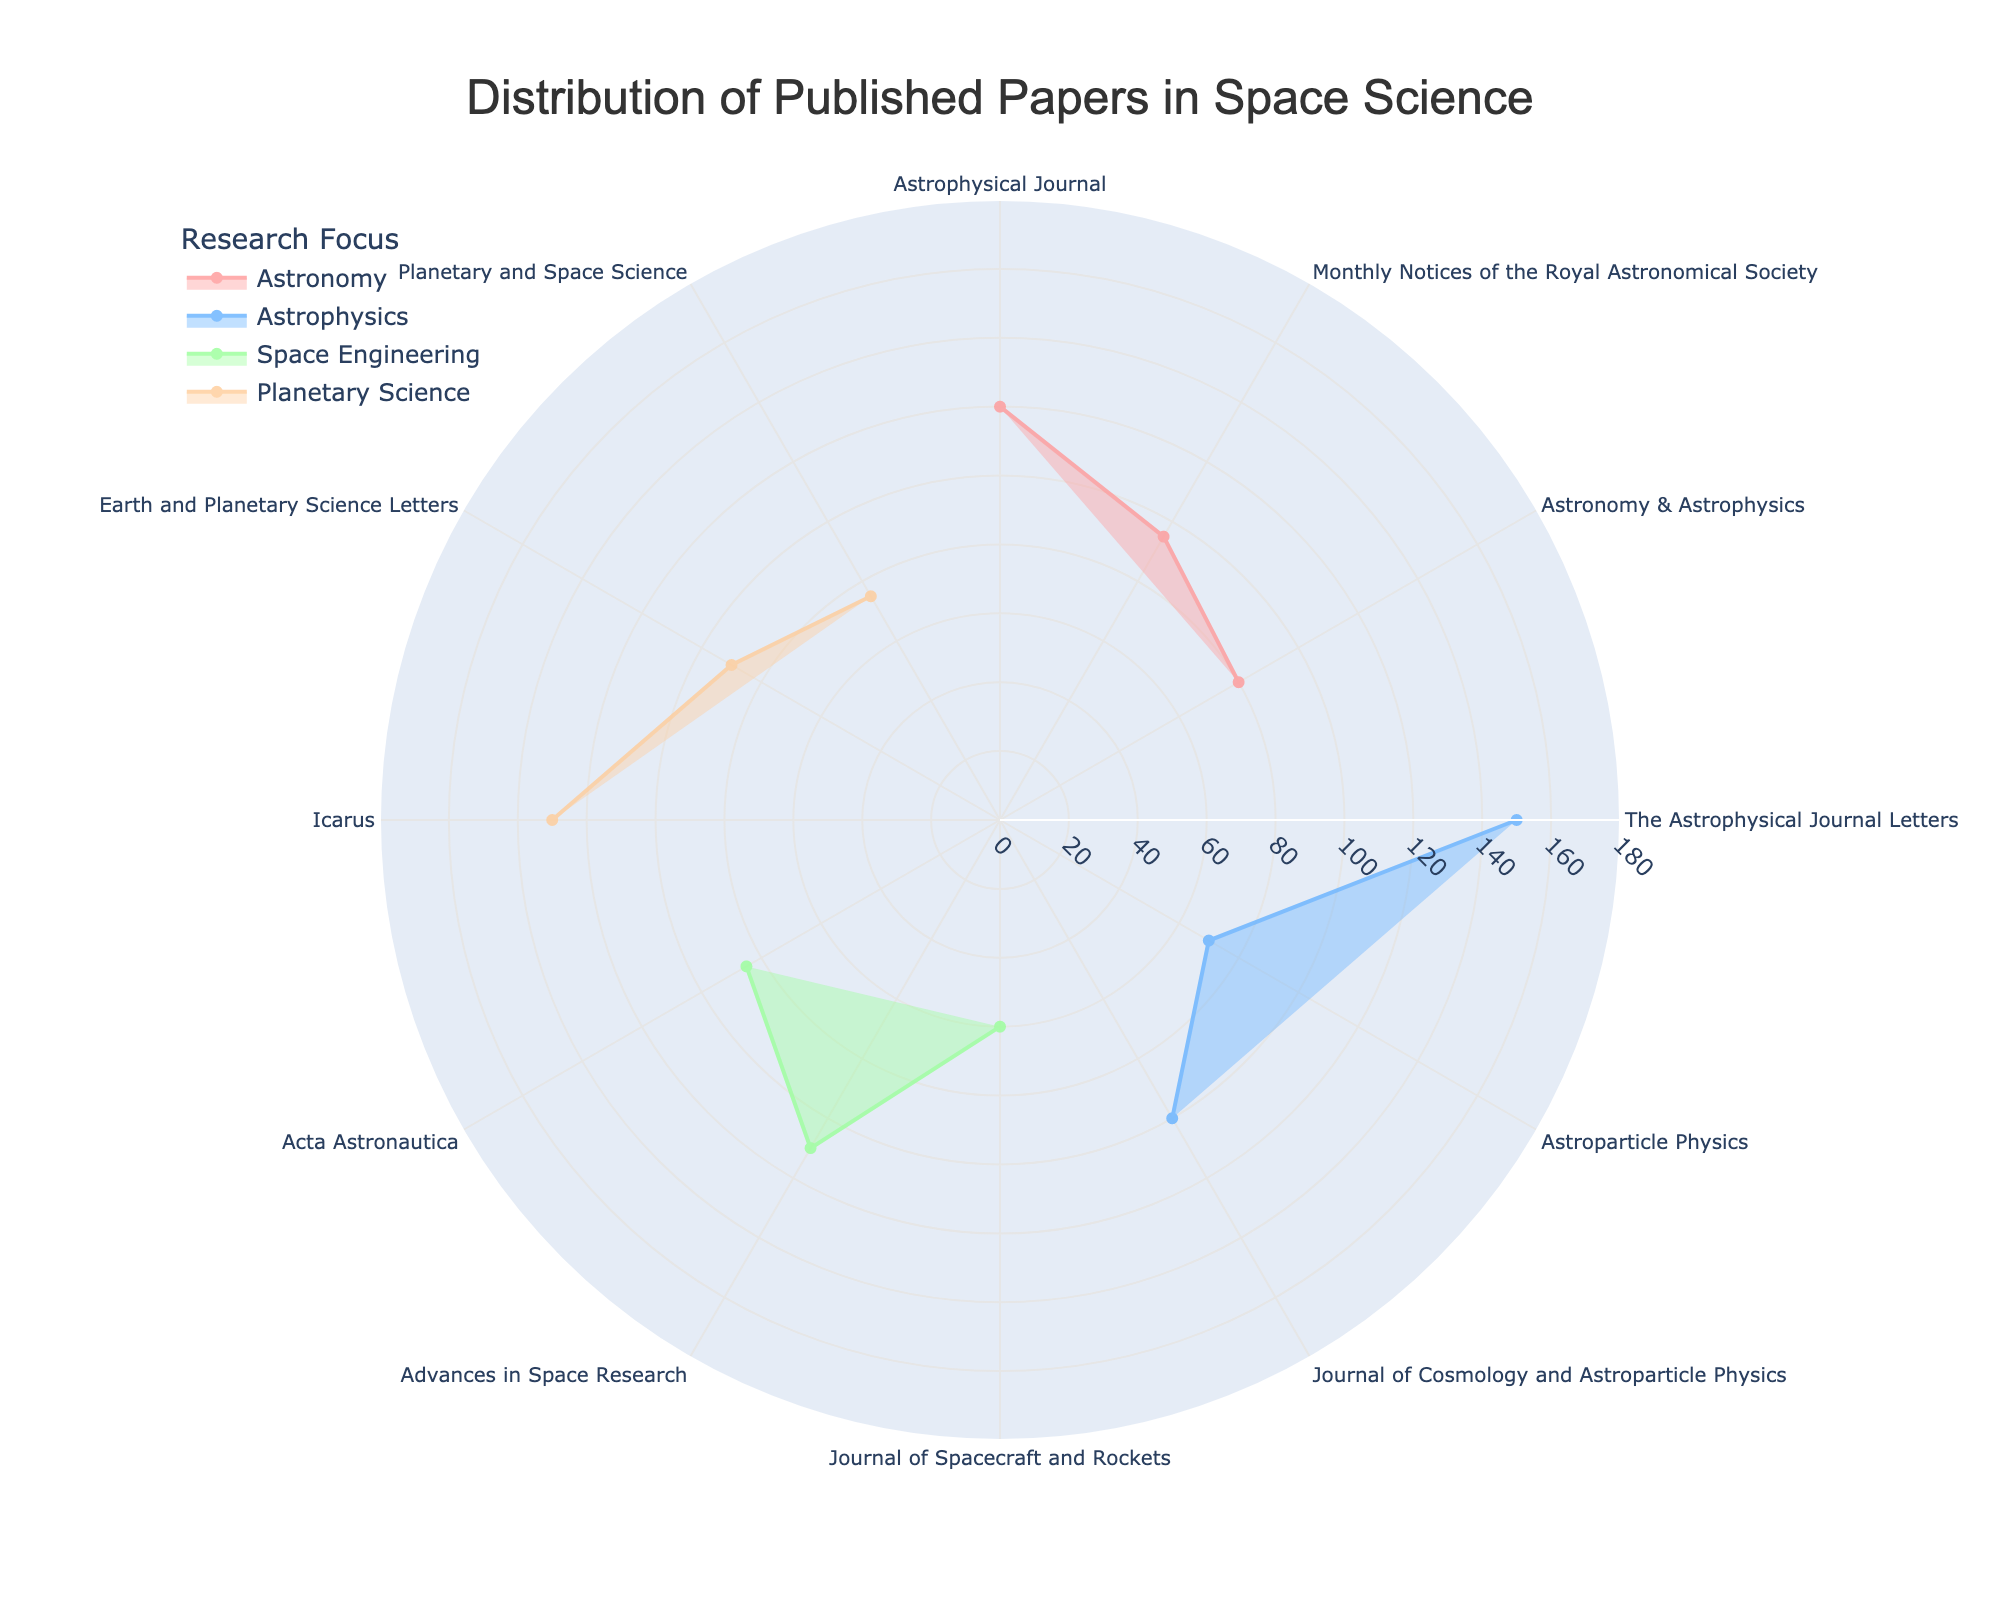What's the title of the figure? The title is prominently displayed at the top of the chart and provides a description of what the figure represents.
Answer: Distribution of Published Papers in Space Science What is the range of the radial axis in the figure? Inspecting the radial axis, we see the range marked on the axis.
Answer: 0 to 180 Which journal published the most papers under "Planetary Science"? By looking at the chart, find the journal label in the "Planetary Science" section with the highest radial value.
Answer: Icarus How many more papers were published in "Astronomy" by the "Astrophysical Journal" than by "Astronomy & Astrophysics"? Find the radial values for both journals and calculate the difference. 120 papers by "Astrophysical Journal" minus 80 papers by "Astronomy & Astrophysics".
Answer: 40 What is the average number of papers published in "Astrophysics"? Calculate the average by summing the papers for each journal in "Astrophysics" and then dividing by the number of journals. (150 + 70 + 100) / 3 = 320 / 3.
Answer: 106.67 Which research focus has the highest total number of published papers? Sum the number of papers for each research focus and compare the totals to identify the highest.
Answer: Astrophysics Are there more papers published by "Journal of Cosmology and Astroparticle Physics" or "Monthly Notices of the Royal Astronomical Society"? Compare the radial values for these two journals within their respective research focuses. 100 for "Journal of Cosmology and Astroparticle Physics" vs. 95 for "Monthly Notices of the Royal Astronomical Society".
Answer: Journal of Cosmology and Astroparticle Physics What percentage of papers published in "Space Engineering" were from "Journal of Spacecraft and Rockets"? Calculate the percentage by dividing the number of papers from "Journal of Spacecraft and Rockets" by the total number of papers in "Space Engineering" and multiplying by 100. (60 / (60 + 110 + 85)) * 100 = (60 / 255) * 100.
Answer: 23.53% Which research focus includes "Earth and Planetary Science Letters"? Inspect the angular axis labels for the journal and identify the associated research focus.
Answer: Planetary Science How does the publication count in "Advances in Space Research" compare to "Acta Astronautica"? Look at the radial values for these journals within "Space Engineering" and compute the difference. 110 for "Advances in Space Research" minus 85 for "Acta Astronautica".
Answer: 25 